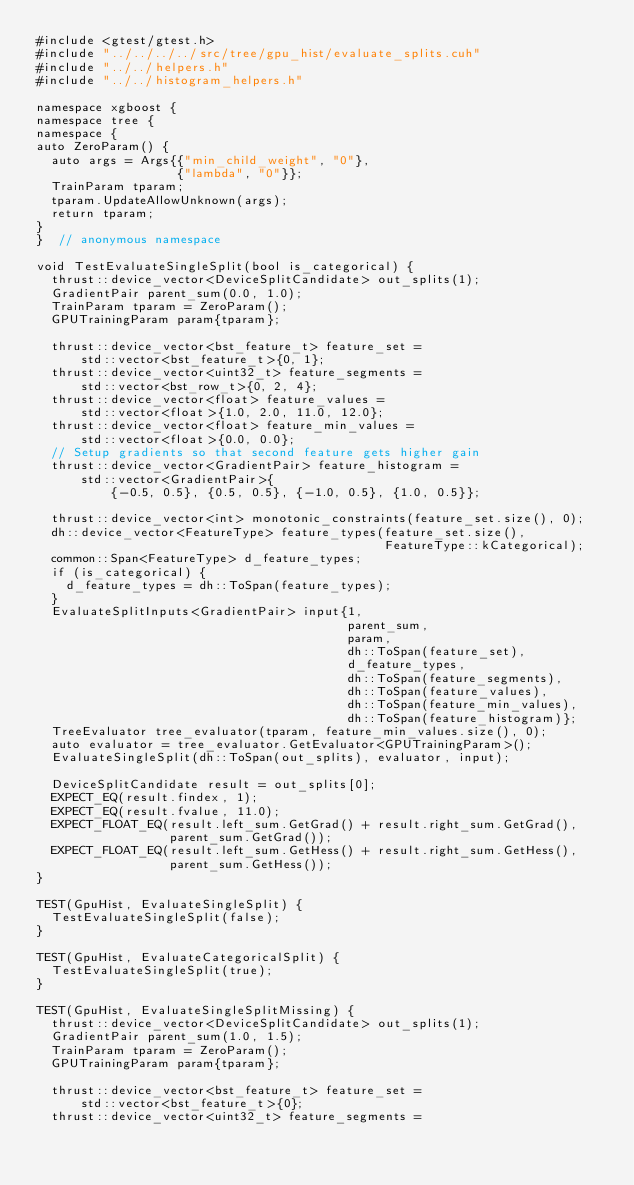<code> <loc_0><loc_0><loc_500><loc_500><_Cuda_>#include <gtest/gtest.h>
#include "../../../../src/tree/gpu_hist/evaluate_splits.cuh"
#include "../../helpers.h"
#include "../../histogram_helpers.h"

namespace xgboost {
namespace tree {
namespace {
auto ZeroParam() {
  auto args = Args{{"min_child_weight", "0"},
                   {"lambda", "0"}};
  TrainParam tparam;
  tparam.UpdateAllowUnknown(args);
  return tparam;
}
}  // anonymous namespace

void TestEvaluateSingleSplit(bool is_categorical) {
  thrust::device_vector<DeviceSplitCandidate> out_splits(1);
  GradientPair parent_sum(0.0, 1.0);
  TrainParam tparam = ZeroParam();
  GPUTrainingParam param{tparam};

  thrust::device_vector<bst_feature_t> feature_set =
      std::vector<bst_feature_t>{0, 1};
  thrust::device_vector<uint32_t> feature_segments =
      std::vector<bst_row_t>{0, 2, 4};
  thrust::device_vector<float> feature_values =
      std::vector<float>{1.0, 2.0, 11.0, 12.0};
  thrust::device_vector<float> feature_min_values =
      std::vector<float>{0.0, 0.0};
  // Setup gradients so that second feature gets higher gain
  thrust::device_vector<GradientPair> feature_histogram =
      std::vector<GradientPair>{
          {-0.5, 0.5}, {0.5, 0.5}, {-1.0, 0.5}, {1.0, 0.5}};

  thrust::device_vector<int> monotonic_constraints(feature_set.size(), 0);
  dh::device_vector<FeatureType> feature_types(feature_set.size(),
                                               FeatureType::kCategorical);
  common::Span<FeatureType> d_feature_types;
  if (is_categorical) {
    d_feature_types = dh::ToSpan(feature_types);
  }
  EvaluateSplitInputs<GradientPair> input{1,
                                          parent_sum,
                                          param,
                                          dh::ToSpan(feature_set),
                                          d_feature_types,
                                          dh::ToSpan(feature_segments),
                                          dh::ToSpan(feature_values),
                                          dh::ToSpan(feature_min_values),
                                          dh::ToSpan(feature_histogram)};
  TreeEvaluator tree_evaluator(tparam, feature_min_values.size(), 0);
  auto evaluator = tree_evaluator.GetEvaluator<GPUTrainingParam>();
  EvaluateSingleSplit(dh::ToSpan(out_splits), evaluator, input);

  DeviceSplitCandidate result = out_splits[0];
  EXPECT_EQ(result.findex, 1);
  EXPECT_EQ(result.fvalue, 11.0);
  EXPECT_FLOAT_EQ(result.left_sum.GetGrad() + result.right_sum.GetGrad(),
                  parent_sum.GetGrad());
  EXPECT_FLOAT_EQ(result.left_sum.GetHess() + result.right_sum.GetHess(),
                  parent_sum.GetHess());
}

TEST(GpuHist, EvaluateSingleSplit) {
  TestEvaluateSingleSplit(false);
}

TEST(GpuHist, EvaluateCategoricalSplit) {
  TestEvaluateSingleSplit(true);
}

TEST(GpuHist, EvaluateSingleSplitMissing) {
  thrust::device_vector<DeviceSplitCandidate> out_splits(1);
  GradientPair parent_sum(1.0, 1.5);
  TrainParam tparam = ZeroParam();
  GPUTrainingParam param{tparam};

  thrust::device_vector<bst_feature_t> feature_set =
      std::vector<bst_feature_t>{0};
  thrust::device_vector<uint32_t> feature_segments =</code> 